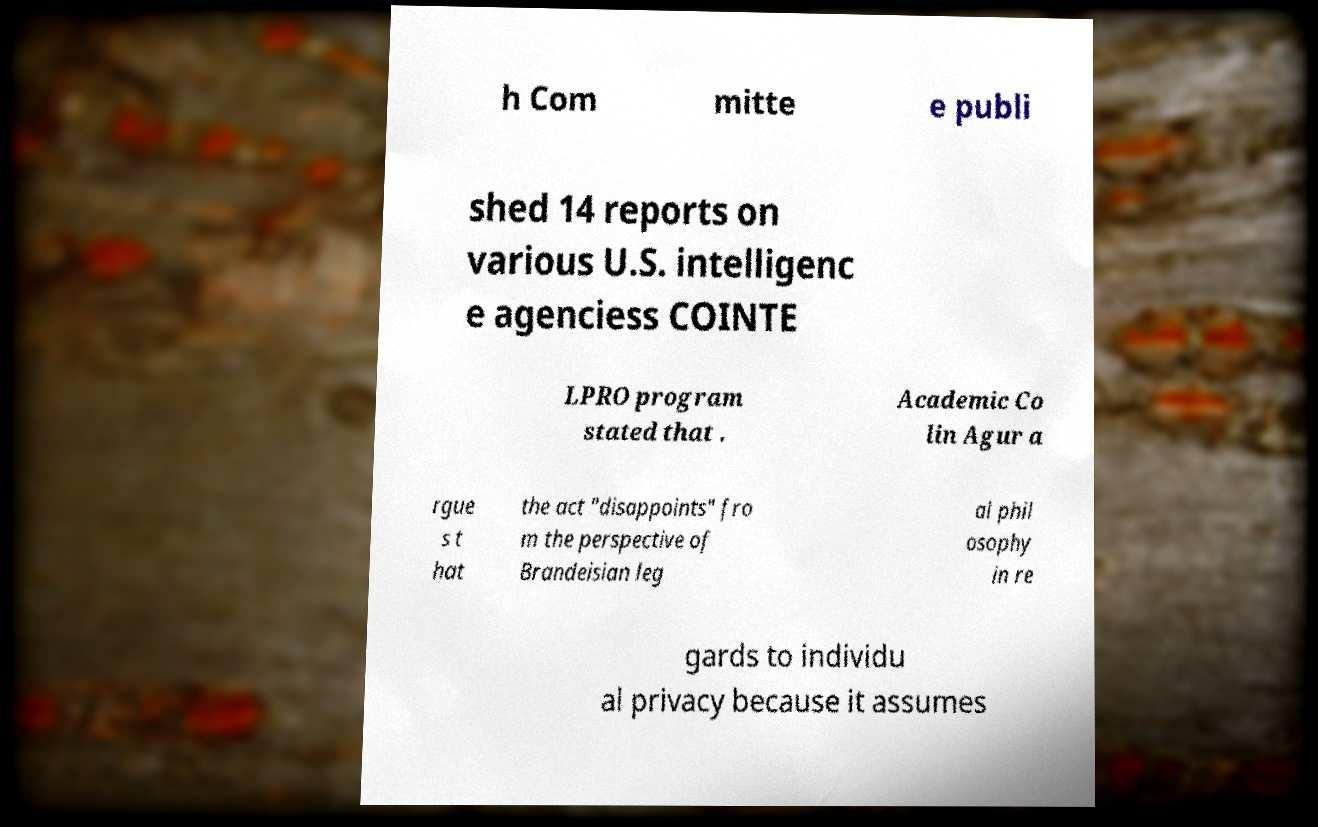There's text embedded in this image that I need extracted. Can you transcribe it verbatim? h Com mitte e publi shed 14 reports on various U.S. intelligenc e agenciess COINTE LPRO program stated that . Academic Co lin Agur a rgue s t hat the act "disappoints" fro m the perspective of Brandeisian leg al phil osophy in re gards to individu al privacy because it assumes 